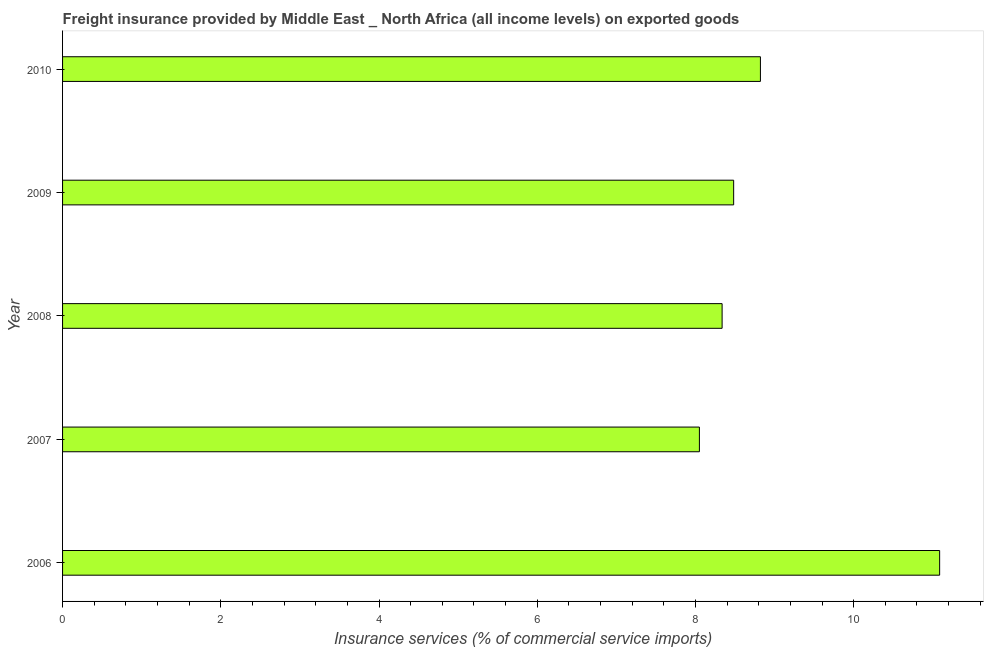Does the graph contain any zero values?
Provide a short and direct response. No. What is the title of the graph?
Your response must be concise. Freight insurance provided by Middle East _ North Africa (all income levels) on exported goods . What is the label or title of the X-axis?
Your answer should be very brief. Insurance services (% of commercial service imports). What is the freight insurance in 2009?
Your answer should be compact. 8.48. Across all years, what is the maximum freight insurance?
Ensure brevity in your answer.  11.09. Across all years, what is the minimum freight insurance?
Ensure brevity in your answer.  8.05. What is the sum of the freight insurance?
Provide a short and direct response. 44.78. What is the difference between the freight insurance in 2006 and 2007?
Make the answer very short. 3.04. What is the average freight insurance per year?
Your answer should be compact. 8.96. What is the median freight insurance?
Ensure brevity in your answer.  8.48. Do a majority of the years between 2008 and 2009 (inclusive) have freight insurance greater than 7.2 %?
Your response must be concise. Yes. What is the ratio of the freight insurance in 2006 to that in 2008?
Keep it short and to the point. 1.33. Is the freight insurance in 2006 less than that in 2007?
Offer a very short reply. No. Is the difference between the freight insurance in 2007 and 2009 greater than the difference between any two years?
Your answer should be very brief. No. What is the difference between the highest and the second highest freight insurance?
Provide a short and direct response. 2.27. What is the difference between the highest and the lowest freight insurance?
Give a very brief answer. 3.04. Are all the bars in the graph horizontal?
Provide a succinct answer. Yes. How many years are there in the graph?
Keep it short and to the point. 5. What is the difference between two consecutive major ticks on the X-axis?
Offer a very short reply. 2. What is the Insurance services (% of commercial service imports) of 2006?
Your answer should be very brief. 11.09. What is the Insurance services (% of commercial service imports) in 2007?
Give a very brief answer. 8.05. What is the Insurance services (% of commercial service imports) of 2008?
Make the answer very short. 8.34. What is the Insurance services (% of commercial service imports) of 2009?
Make the answer very short. 8.48. What is the Insurance services (% of commercial service imports) of 2010?
Provide a short and direct response. 8.82. What is the difference between the Insurance services (% of commercial service imports) in 2006 and 2007?
Make the answer very short. 3.04. What is the difference between the Insurance services (% of commercial service imports) in 2006 and 2008?
Provide a short and direct response. 2.75. What is the difference between the Insurance services (% of commercial service imports) in 2006 and 2009?
Provide a short and direct response. 2.6. What is the difference between the Insurance services (% of commercial service imports) in 2006 and 2010?
Provide a short and direct response. 2.27. What is the difference between the Insurance services (% of commercial service imports) in 2007 and 2008?
Your answer should be compact. -0.29. What is the difference between the Insurance services (% of commercial service imports) in 2007 and 2009?
Offer a very short reply. -0.43. What is the difference between the Insurance services (% of commercial service imports) in 2007 and 2010?
Offer a very short reply. -0.77. What is the difference between the Insurance services (% of commercial service imports) in 2008 and 2009?
Ensure brevity in your answer.  -0.15. What is the difference between the Insurance services (% of commercial service imports) in 2008 and 2010?
Keep it short and to the point. -0.48. What is the difference between the Insurance services (% of commercial service imports) in 2009 and 2010?
Provide a succinct answer. -0.34. What is the ratio of the Insurance services (% of commercial service imports) in 2006 to that in 2007?
Make the answer very short. 1.38. What is the ratio of the Insurance services (% of commercial service imports) in 2006 to that in 2008?
Ensure brevity in your answer.  1.33. What is the ratio of the Insurance services (% of commercial service imports) in 2006 to that in 2009?
Your response must be concise. 1.31. What is the ratio of the Insurance services (% of commercial service imports) in 2006 to that in 2010?
Keep it short and to the point. 1.26. What is the ratio of the Insurance services (% of commercial service imports) in 2007 to that in 2008?
Ensure brevity in your answer.  0.97. What is the ratio of the Insurance services (% of commercial service imports) in 2007 to that in 2009?
Offer a very short reply. 0.95. What is the ratio of the Insurance services (% of commercial service imports) in 2008 to that in 2009?
Your answer should be compact. 0.98. What is the ratio of the Insurance services (% of commercial service imports) in 2008 to that in 2010?
Make the answer very short. 0.94. What is the ratio of the Insurance services (% of commercial service imports) in 2009 to that in 2010?
Ensure brevity in your answer.  0.96. 